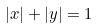Convert formula to latex. <formula><loc_0><loc_0><loc_500><loc_500>| x | + | y | = 1</formula> 